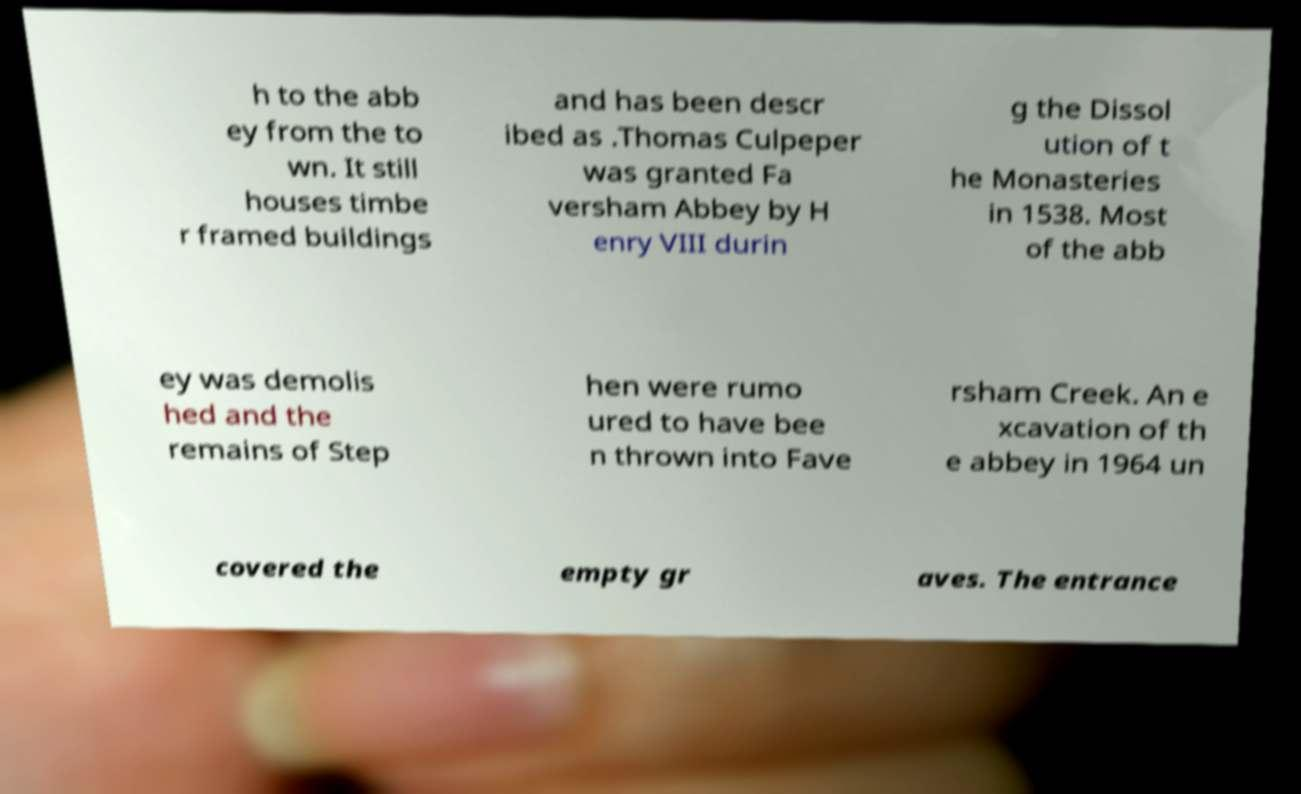Could you assist in decoding the text presented in this image and type it out clearly? h to the abb ey from the to wn. It still houses timbe r framed buildings and has been descr ibed as .Thomas Culpeper was granted Fa versham Abbey by H enry VIII durin g the Dissol ution of t he Monasteries in 1538. Most of the abb ey was demolis hed and the remains of Step hen were rumo ured to have bee n thrown into Fave rsham Creek. An e xcavation of th e abbey in 1964 un covered the empty gr aves. The entrance 